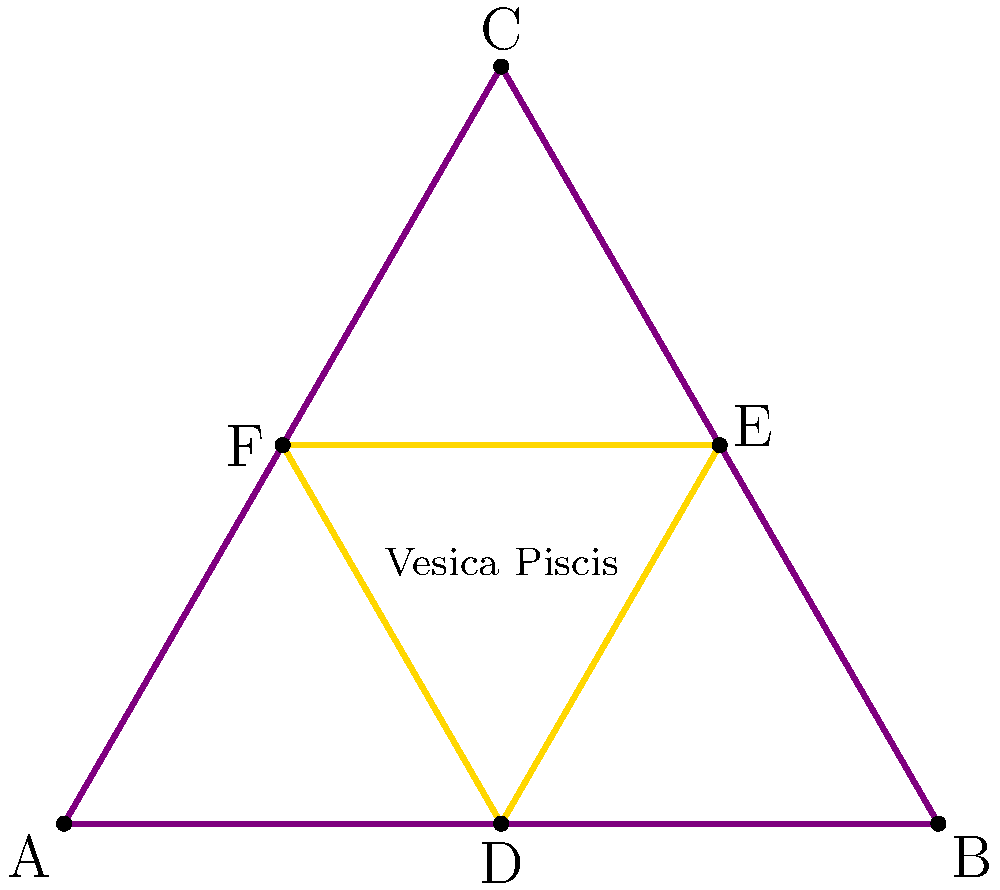In the sacred geometry pattern shown above, how does the relationship between the outer triangle ABC and the inner triangle DEF relate to the concept of the "divine proportion" in poetry? Explain how this geometric structure could be used to inform the verse structure of a spiritually-themed poem. 1. Identify the geometric pattern: The diagram shows an equilateral triangle ABC with an inscribed triangle DEF. This configuration is related to the Vesica Piscis, a fundamental shape in sacred geometry.

2. Divine proportion connection:
   a. The ratio of the area of the outer triangle to the inner triangle approximates the golden ratio, φ ≈ 1.618.
   b. This ratio is often referred to as the "divine proportion" in art and nature.

3. Poetic application:
   a. Syllable count: The number of syllables in each line or stanza could follow the Fibonacci sequence (1, 1, 2, 3, 5, 8, 13, 21...), which converges to the golden ratio.
   b. Line length: The ratio of longer lines to shorter lines could mirror the divine proportion.
   c. Stanza structure: A poem could have 3 main sections (like the outer triangle) with 3 subsections each (like the inner triangle).

4. Spiritual themes:
   a. Trinity concept: The triangular shape can represent spiritual triads (e.g., body-mind-spirit).
   b. Interconnectedness: The intertwining of the triangles symbolizes the connection between the physical and spiritual realms.

5. Verse structure example:
   a. Create a 3-3-3 syllable pattern for the first stanza (representing the inner triangle).
   b. Follow with a 5-5-5 syllable pattern for the second stanza (representing the outer triangle).
   c. Conclude with an 8-8-8 syllable pattern, showing growth and expansion.

6. Thematic integration:
   a. Use the Vesica Piscis shape as a metaphor for spiritual awakening or the meeting of heaven and earth.
   b. Incorporate themes of balance, harmony, and divine order reflected in the geometric symmetry.

By structuring the poem according to these sacred geometry principles, the poet can create a verse that not only discusses spiritual themes but embodies them in its very form.
Answer: 3-3-3, 5-5-5, 8-8-8 syllable structure mirroring triangular sacred geometry 